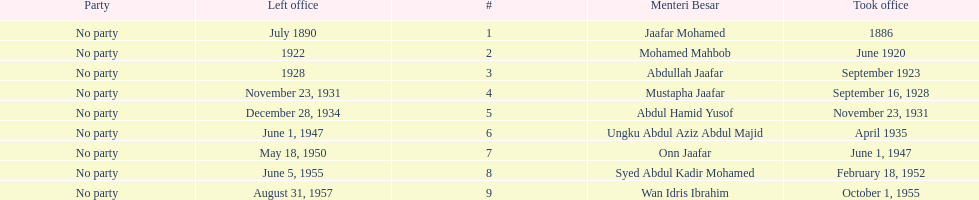How long did ungku abdul aziz abdul majid serve? 12 years. 